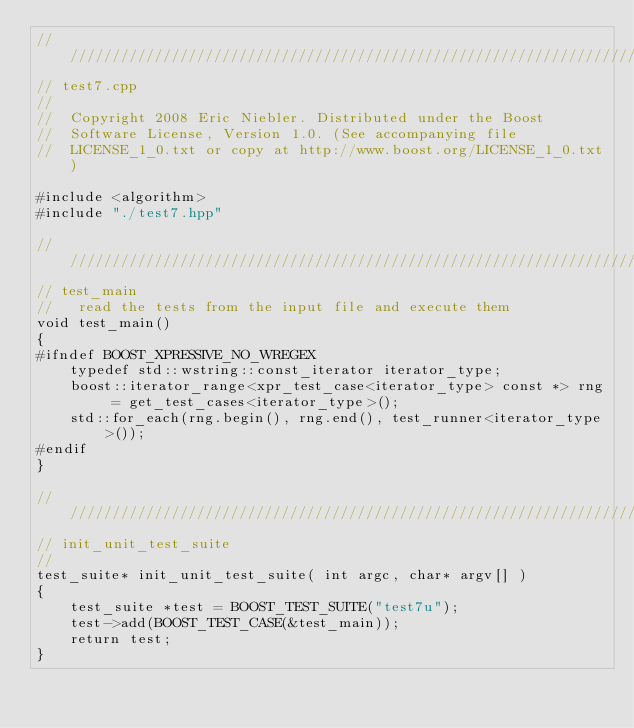Convert code to text. <code><loc_0><loc_0><loc_500><loc_500><_C++_>///////////////////////////////////////////////////////////////////////////////
// test7.cpp
//
//  Copyright 2008 Eric Niebler. Distributed under the Boost
//  Software License, Version 1.0. (See accompanying file
//  LICENSE_1_0.txt or copy at http://www.boost.org/LICENSE_1_0.txt)

#include <algorithm>
#include "./test7.hpp"

///////////////////////////////////////////////////////////////////////////////
// test_main
//   read the tests from the input file and execute them
void test_main()
{
#ifndef BOOST_XPRESSIVE_NO_WREGEX
    typedef std::wstring::const_iterator iterator_type;
    boost::iterator_range<xpr_test_case<iterator_type> const *> rng = get_test_cases<iterator_type>();
    std::for_each(rng.begin(), rng.end(), test_runner<iterator_type>());
#endif
}

///////////////////////////////////////////////////////////////////////////////
// init_unit_test_suite
//
test_suite* init_unit_test_suite( int argc, char* argv[] )
{
    test_suite *test = BOOST_TEST_SUITE("test7u");
    test->add(BOOST_TEST_CASE(&test_main));
    return test;
}
</code> 